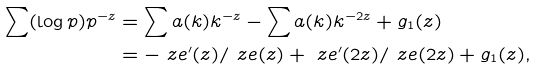Convert formula to latex. <formula><loc_0><loc_0><loc_500><loc_500>\sum ( \log p ) p ^ { - z } & = \sum \L a ( k ) k ^ { - z } - \sum \L a ( k ) k ^ { - 2 z } + g _ { 1 } ( z ) \\ & = - \ z e ^ { \prime } ( z ) / \ z e ( z ) + \ z e ^ { \prime } ( 2 z ) / \ z e ( 2 z ) + g _ { 1 } ( z ) ,</formula> 